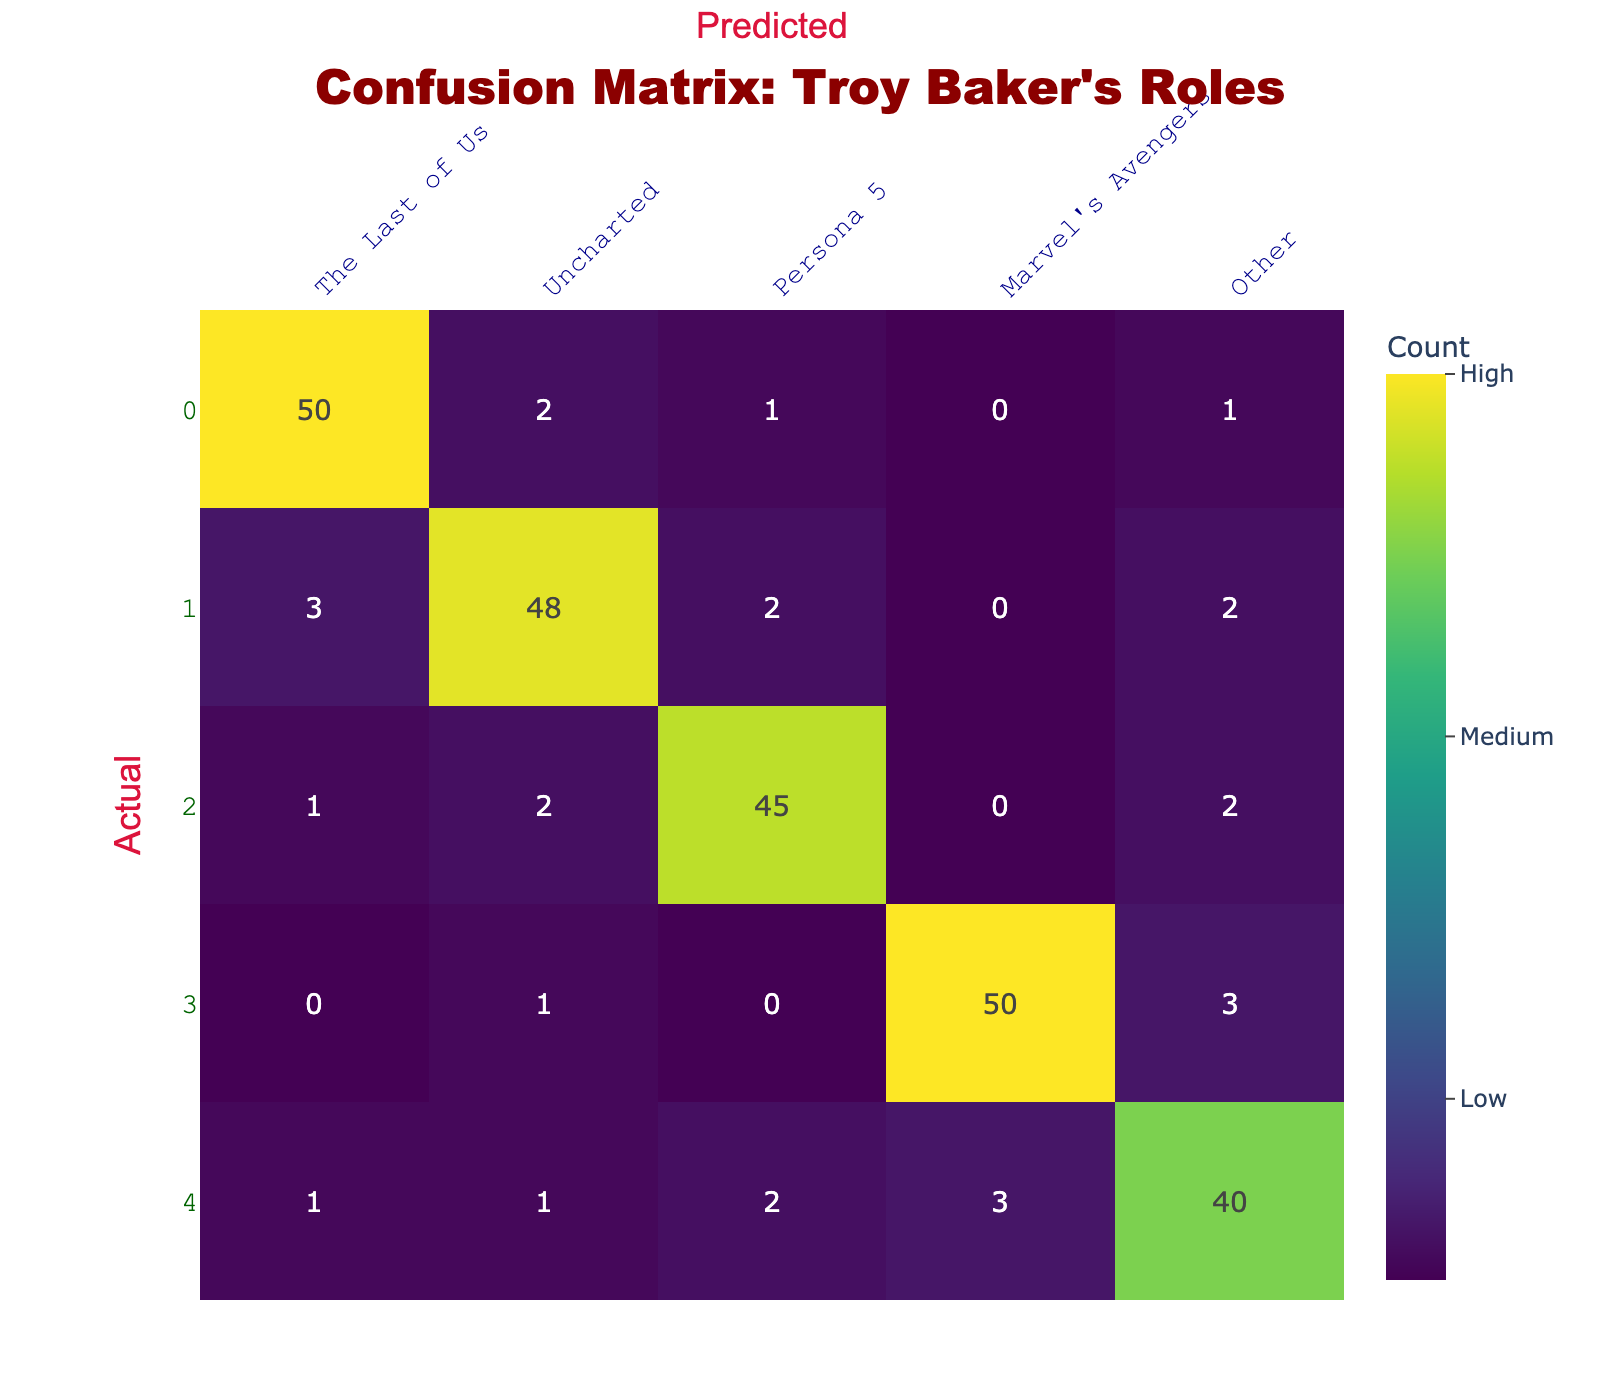What is the number of fan responses categorized under "The Last of Us"? From the table, we look at the row for "The Last of Us". The total number of responses is the sum of the values in that row: 50 (The Last of Us) + 2 (Uncharted) + 1 (Persona 5) + 0 (Marvel's Avengers) + 1 (Other) = 54.
Answer: 54 What is the total number of fan responses for "Marvel's Avengers"? To find this, we check the row for "Marvel's Avengers" and sum the values: 0 (The Last of Us) + 1 (Uncharted) + 0 (Persona 5) + 50 (Marvel's Avengers) + 3 (Other) = 54.
Answer: 54 Is the number of predicted responses for "Uncharted" greater than the actual responses for "The Last of Us"? From the table, the actual responses for "The Last of Us" is 50, while predicted responses for "Uncharted" is 48. Since 48 is less than 50, the answer is no.
Answer: No What is the average number of responses predicted for "Other" across all actual categories? To find the average, we sum the predicted values for "Other": 1 (The Last of Us) + 2 (Uncharted) + 2 (Persona 5) + 3 (Marvel's Avengers) + 40 (Other) = 48. Then we have 5 categories, so the average is 48/5 = 9.6.
Answer: 9.6 Which role received the highest number of actual fan responses? The highest response is found in the "The Last of Us" row, which has 50 actual responses. Evaluating all rows reveals that no other category exceeds four.
Answer: The Last of Us How many responses were either misclassified as "Uncharted" from "The Last of Us" or as "Other"? We examine the table and find that 3 responses from "The Last of Us" were classified as "Uncharted" and 1 response from "The Last of Us" was classified as "Other". Combining these gives us 3 + 1 = 4 responses.
Answer: 4 What percentage of total responses comes from "Persona 5"? First, we need the total number of responses, which is the sum of all values in the table: 50 + 2 + 1 + 0 + 1 + 3 + 48 + 2 + 0 + 2 + 45 + 0 + 2 + 0 + 50 + 3 + 1 + 1 + 2 + 3 + 40 = 220. "Persona 5" has 45 actual responses. Then, the percentage is (45/220) * 100 = 20.45%.
Answer: 20.45% Is it true that more responses were predicted for "Other" than for "The Last of Us"? The predicted responses for "Other" are 40, while the predicted responses for "The Last of Us" are 50. Since 40 is less than 50, the answer is no.
Answer: No 